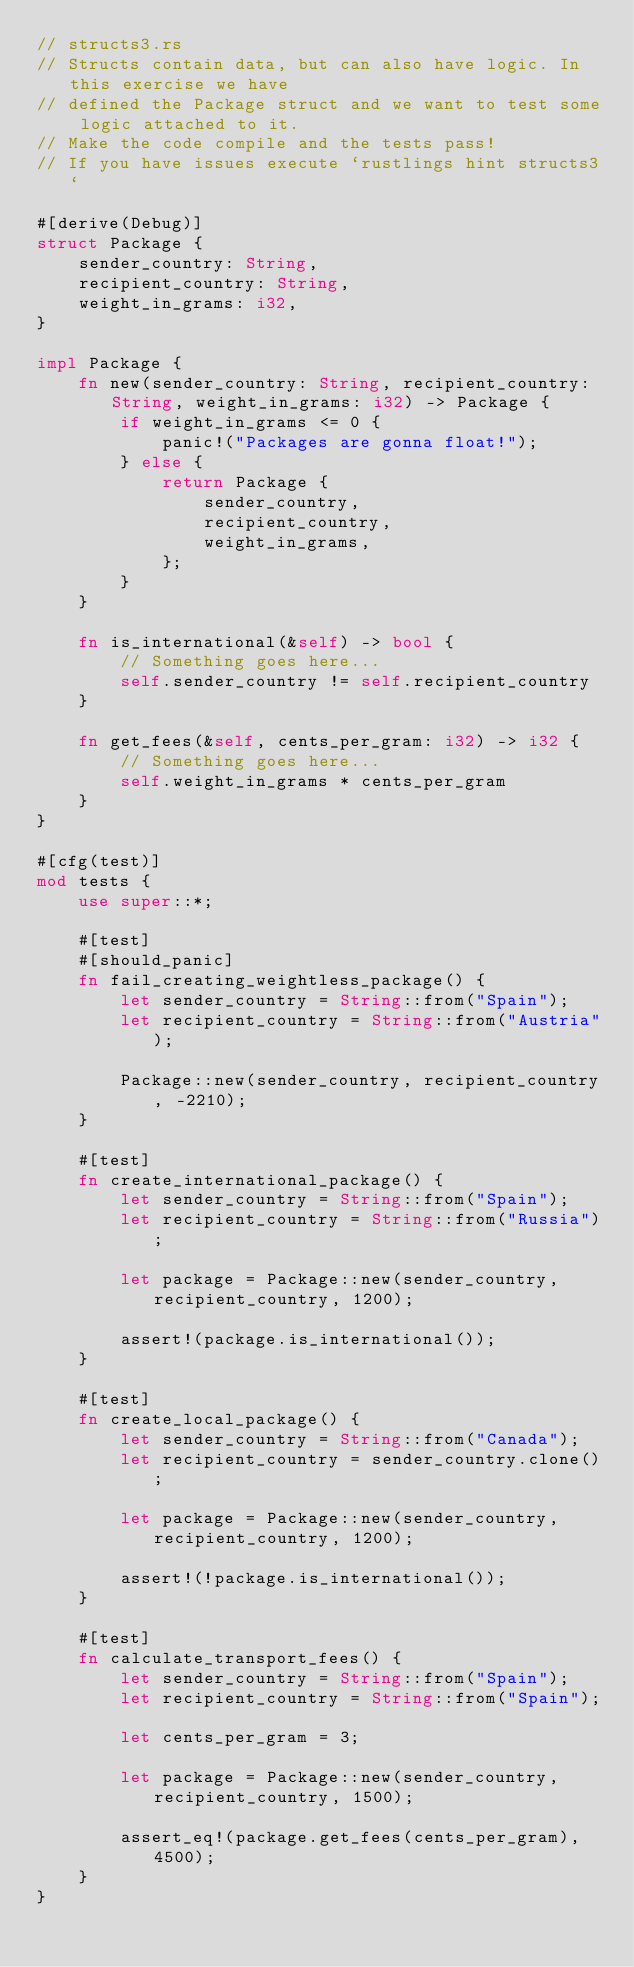Convert code to text. <code><loc_0><loc_0><loc_500><loc_500><_Rust_>// structs3.rs
// Structs contain data, but can also have logic. In this exercise we have
// defined the Package struct and we want to test some logic attached to it.
// Make the code compile and the tests pass!
// If you have issues execute `rustlings hint structs3`

#[derive(Debug)]
struct Package {
    sender_country: String,
    recipient_country: String,
    weight_in_grams: i32,
}

impl Package {
    fn new(sender_country: String, recipient_country: String, weight_in_grams: i32) -> Package {
        if weight_in_grams <= 0 {
            panic!("Packages are gonna float!");
        } else {
            return Package {
                sender_country,
                recipient_country,
                weight_in_grams,
            };
        }
    }

    fn is_international(&self) -> bool {
        // Something goes here...
        self.sender_country != self.recipient_country 
    }

    fn get_fees(&self, cents_per_gram: i32) -> i32 {
        // Something goes here...
        self.weight_in_grams * cents_per_gram
    }
}

#[cfg(test)]
mod tests {
    use super::*;

    #[test]
    #[should_panic]
    fn fail_creating_weightless_package() {
        let sender_country = String::from("Spain");
        let recipient_country = String::from("Austria");

        Package::new(sender_country, recipient_country, -2210);
    }

    #[test]
    fn create_international_package() {
        let sender_country = String::from("Spain");
        let recipient_country = String::from("Russia");

        let package = Package::new(sender_country, recipient_country, 1200);

        assert!(package.is_international());
    }

    #[test]
    fn create_local_package() {
        let sender_country = String::from("Canada");
        let recipient_country = sender_country.clone();

        let package = Package::new(sender_country, recipient_country, 1200);

        assert!(!package.is_international());
    }

    #[test]
    fn calculate_transport_fees() {
        let sender_country = String::from("Spain");
        let recipient_country = String::from("Spain");

        let cents_per_gram = 3;

        let package = Package::new(sender_country, recipient_country, 1500);

        assert_eq!(package.get_fees(cents_per_gram), 4500);
    }
}
</code> 